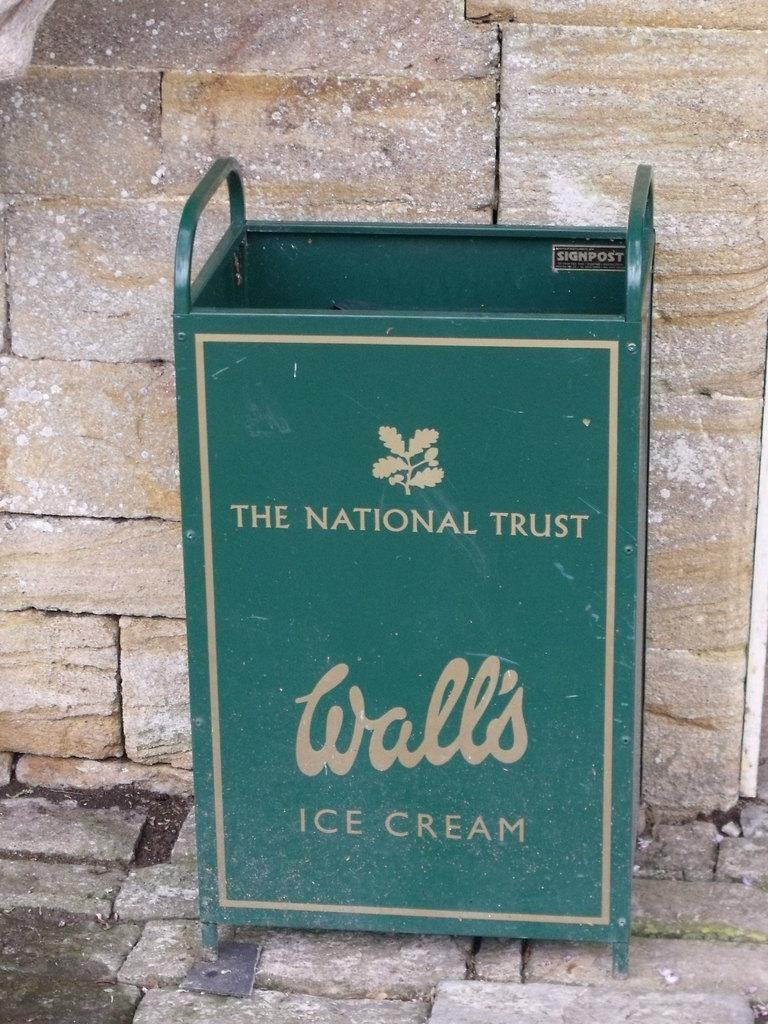<image>
Provide a brief description of the given image. A trash can that is advertising Wall's ice cream 